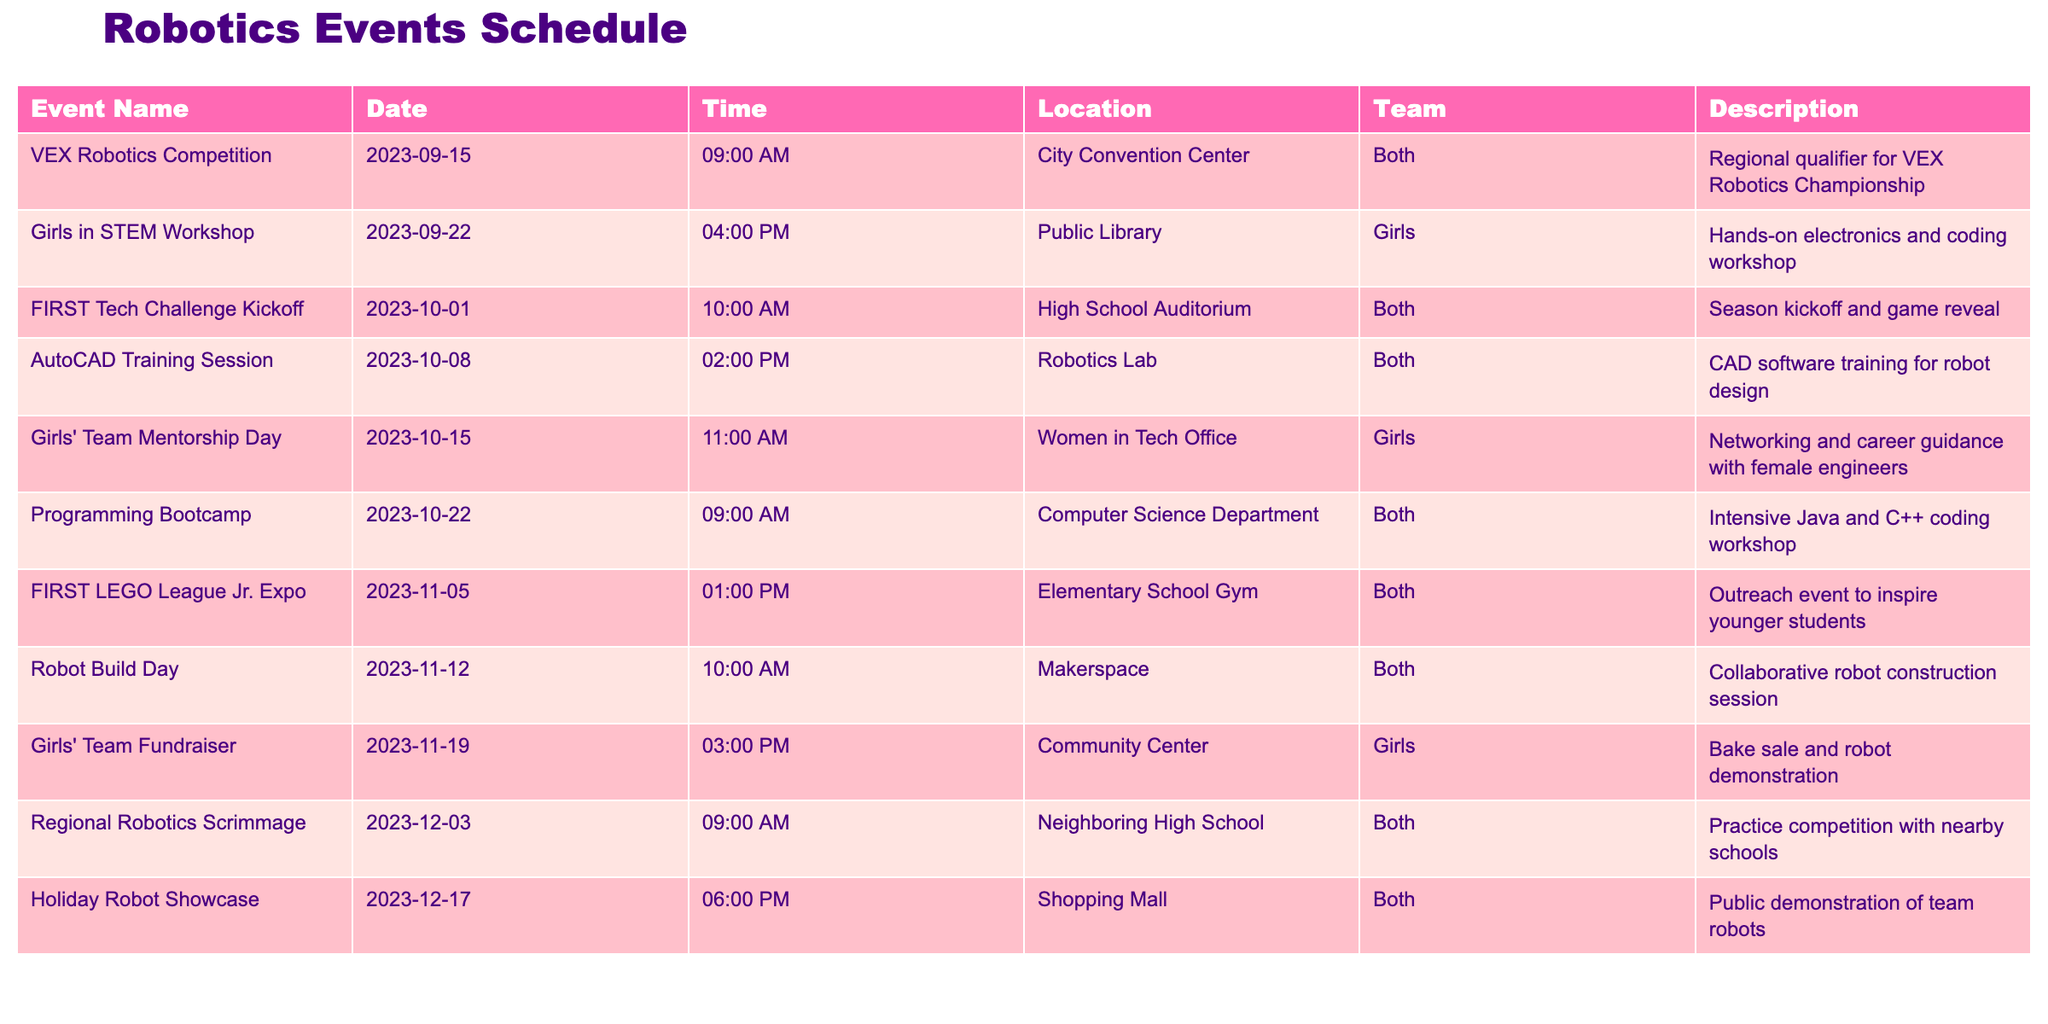What is the date of the Girls in STEM Workshop? Referring to the table, the Girls in STEM Workshop is listed on the date of 2023-09-22.
Answer: 2023-09-22 How many events are scheduled for the girls' team? Upon reviewing the table, there are three events specifically for the girls' team: Girls in STEM Workshop, Girls' Team Mentorship Day, and Girls' Team Fundraiser.
Answer: 3 What time does the FIRST Tech Challenge Kickoff start? The table indicates that the FIRST Tech Challenge Kickoff starts at 10:00 AM.
Answer: 10:00 AM Is there a robotics event specifically for the girls' team on October 15th? Yes, the table shows that there is a Girls' Team Mentorship Day on October 15th specifically for the girls' team.
Answer: Yes Which event occurs later, the Robot Build Day or the Holiday Robot Showcase? By comparing the dates, the Robot Build Day is on November 12th and the Holiday Robot Showcase is on December 17th. Since December is later than November, the Holiday Robot Showcase occurs later.
Answer: Holiday Robot Showcase How many total events are scheduled for both teams combined? The table lists a total of ten events, six of which are for both teams and three for the girls' team, plus one that is common to both.
Answer: 10 On what days do events occur in November? Referring to the table, the events in November are scheduled on the 5th (FIRST LEGO League Jr. Expo), 12th (Robot Build Day), and 19th (Girls' Team Fundraiser).
Answer: November 5, 12, 19 What’s the difference in time between the Girls in STEM Workshop and the Programming Bootcamp? The Girls in STEM Workshop starts at 4:00 PM and the Programming Bootcamp starts at 9:00 AM on separate days. The time difference between them is 7 hours.
Answer: 7 hours How many workshops focus on coding specifically? The Girls in STEM Workshop and the Programming Bootcamp both focus on coding. Thus, there are two workshops in total on this theme.
Answer: 2 Are there any events that fall on a Sunday? Checking the dates, November 5th and December 3rd are both Sundays. Therefore, there are two events that fall on Sunday.
Answer: Yes 